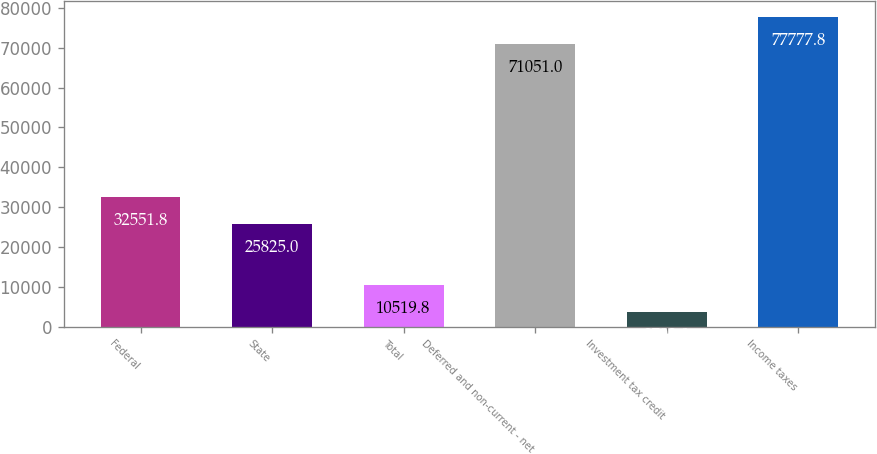Convert chart. <chart><loc_0><loc_0><loc_500><loc_500><bar_chart><fcel>Federal<fcel>State<fcel>Total<fcel>Deferred and non-current - net<fcel>Investment tax credit<fcel>Income taxes<nl><fcel>32551.8<fcel>25825<fcel>10519.8<fcel>71051<fcel>3793<fcel>77777.8<nl></chart> 